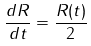<formula> <loc_0><loc_0><loc_500><loc_500>\frac { d R } { d t } = \frac { R ( t ) } { 2 }</formula> 